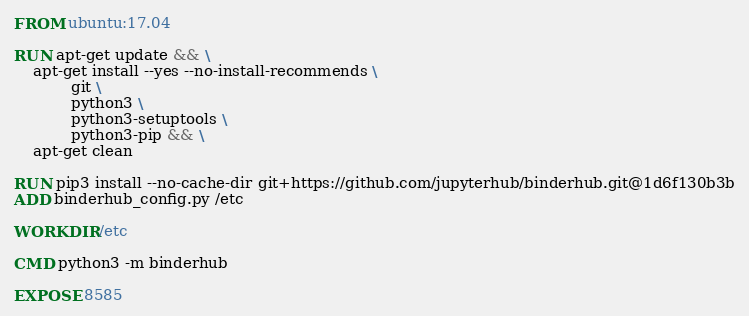Convert code to text. <code><loc_0><loc_0><loc_500><loc_500><_Dockerfile_>FROM ubuntu:17.04

RUN apt-get update && \
    apt-get install --yes --no-install-recommends \
            git \
            python3 \
            python3-setuptools \
            python3-pip && \
    apt-get clean

RUN pip3 install --no-cache-dir git+https://github.com/jupyterhub/binderhub.git@1d6f130b3b
ADD binderhub_config.py /etc

WORKDIR /etc

CMD python3 -m binderhub

EXPOSE 8585
</code> 